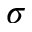<formula> <loc_0><loc_0><loc_500><loc_500>\sigma</formula> 